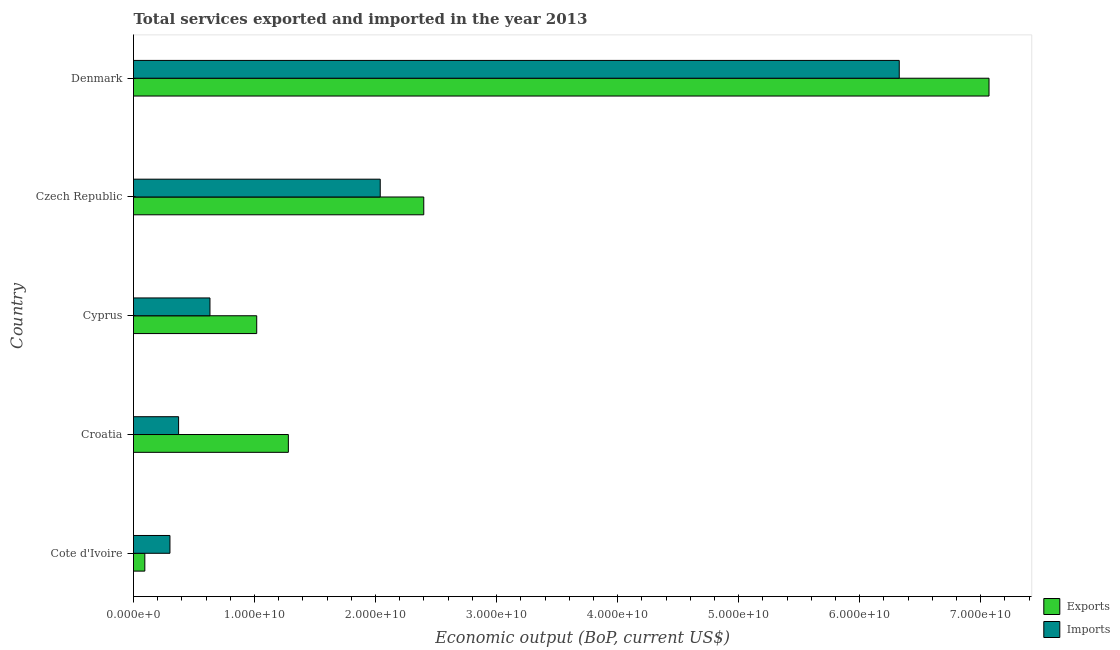How many groups of bars are there?
Keep it short and to the point. 5. Are the number of bars per tick equal to the number of legend labels?
Ensure brevity in your answer.  Yes. Are the number of bars on each tick of the Y-axis equal?
Offer a very short reply. Yes. How many bars are there on the 4th tick from the top?
Your response must be concise. 2. How many bars are there on the 1st tick from the bottom?
Your response must be concise. 2. What is the label of the 3rd group of bars from the top?
Your answer should be compact. Cyprus. In how many cases, is the number of bars for a given country not equal to the number of legend labels?
Your response must be concise. 0. What is the amount of service exports in Czech Republic?
Your response must be concise. 2.40e+1. Across all countries, what is the maximum amount of service imports?
Your response must be concise. 6.33e+1. Across all countries, what is the minimum amount of service exports?
Ensure brevity in your answer.  9.35e+08. In which country was the amount of service exports minimum?
Your answer should be compact. Cote d'Ivoire. What is the total amount of service exports in the graph?
Offer a very short reply. 1.19e+11. What is the difference between the amount of service exports in Cote d'Ivoire and that in Denmark?
Ensure brevity in your answer.  -6.98e+1. What is the difference between the amount of service imports in Czech Republic and the amount of service exports in Cyprus?
Your answer should be compact. 1.02e+1. What is the average amount of service exports per country?
Your response must be concise. 2.37e+1. What is the difference between the amount of service exports and amount of service imports in Cote d'Ivoire?
Your response must be concise. -2.08e+09. In how many countries, is the amount of service imports greater than 40000000000 US$?
Give a very brief answer. 1. What is the ratio of the amount of service imports in Czech Republic to that in Denmark?
Provide a succinct answer. 0.32. Is the difference between the amount of service exports in Cote d'Ivoire and Cyprus greater than the difference between the amount of service imports in Cote d'Ivoire and Cyprus?
Keep it short and to the point. No. What is the difference between the highest and the second highest amount of service exports?
Offer a very short reply. 4.67e+1. What is the difference between the highest and the lowest amount of service imports?
Ensure brevity in your answer.  6.03e+1. What does the 1st bar from the top in Cyprus represents?
Ensure brevity in your answer.  Imports. What does the 2nd bar from the bottom in Croatia represents?
Ensure brevity in your answer.  Imports. How many bars are there?
Your answer should be very brief. 10. How many countries are there in the graph?
Keep it short and to the point. 5. What is the difference between two consecutive major ticks on the X-axis?
Ensure brevity in your answer.  1.00e+1. Does the graph contain any zero values?
Keep it short and to the point. No. How are the legend labels stacked?
Offer a terse response. Vertical. What is the title of the graph?
Offer a terse response. Total services exported and imported in the year 2013. Does "Start a business" appear as one of the legend labels in the graph?
Your answer should be very brief. No. What is the label or title of the X-axis?
Your response must be concise. Economic output (BoP, current US$). What is the Economic output (BoP, current US$) of Exports in Cote d'Ivoire?
Make the answer very short. 9.35e+08. What is the Economic output (BoP, current US$) of Imports in Cote d'Ivoire?
Give a very brief answer. 3.01e+09. What is the Economic output (BoP, current US$) in Exports in Croatia?
Offer a terse response. 1.28e+1. What is the Economic output (BoP, current US$) of Imports in Croatia?
Your response must be concise. 3.73e+09. What is the Economic output (BoP, current US$) of Exports in Cyprus?
Provide a succinct answer. 1.02e+1. What is the Economic output (BoP, current US$) of Imports in Cyprus?
Your answer should be compact. 6.32e+09. What is the Economic output (BoP, current US$) in Exports in Czech Republic?
Your response must be concise. 2.40e+1. What is the Economic output (BoP, current US$) in Imports in Czech Republic?
Your answer should be compact. 2.04e+1. What is the Economic output (BoP, current US$) of Exports in Denmark?
Provide a short and direct response. 7.07e+1. What is the Economic output (BoP, current US$) in Imports in Denmark?
Offer a terse response. 6.33e+1. Across all countries, what is the maximum Economic output (BoP, current US$) of Exports?
Give a very brief answer. 7.07e+1. Across all countries, what is the maximum Economic output (BoP, current US$) in Imports?
Give a very brief answer. 6.33e+1. Across all countries, what is the minimum Economic output (BoP, current US$) in Exports?
Your answer should be compact. 9.35e+08. Across all countries, what is the minimum Economic output (BoP, current US$) in Imports?
Keep it short and to the point. 3.01e+09. What is the total Economic output (BoP, current US$) in Exports in the graph?
Offer a very short reply. 1.19e+11. What is the total Economic output (BoP, current US$) in Imports in the graph?
Offer a terse response. 9.67e+1. What is the difference between the Economic output (BoP, current US$) in Exports in Cote d'Ivoire and that in Croatia?
Provide a succinct answer. -1.19e+1. What is the difference between the Economic output (BoP, current US$) of Imports in Cote d'Ivoire and that in Croatia?
Provide a succinct answer. -7.14e+08. What is the difference between the Economic output (BoP, current US$) in Exports in Cote d'Ivoire and that in Cyprus?
Make the answer very short. -9.25e+09. What is the difference between the Economic output (BoP, current US$) of Imports in Cote d'Ivoire and that in Cyprus?
Make the answer very short. -3.31e+09. What is the difference between the Economic output (BoP, current US$) in Exports in Cote d'Ivoire and that in Czech Republic?
Your answer should be very brief. -2.30e+1. What is the difference between the Economic output (BoP, current US$) of Imports in Cote d'Ivoire and that in Czech Republic?
Make the answer very short. -1.74e+1. What is the difference between the Economic output (BoP, current US$) of Exports in Cote d'Ivoire and that in Denmark?
Ensure brevity in your answer.  -6.98e+1. What is the difference between the Economic output (BoP, current US$) of Imports in Cote d'Ivoire and that in Denmark?
Provide a succinct answer. -6.03e+1. What is the difference between the Economic output (BoP, current US$) of Exports in Croatia and that in Cyprus?
Provide a short and direct response. 2.61e+09. What is the difference between the Economic output (BoP, current US$) in Imports in Croatia and that in Cyprus?
Your answer should be very brief. -2.59e+09. What is the difference between the Economic output (BoP, current US$) in Exports in Croatia and that in Czech Republic?
Your answer should be compact. -1.12e+1. What is the difference between the Economic output (BoP, current US$) of Imports in Croatia and that in Czech Republic?
Keep it short and to the point. -1.67e+1. What is the difference between the Economic output (BoP, current US$) in Exports in Croatia and that in Denmark?
Your answer should be very brief. -5.79e+1. What is the difference between the Economic output (BoP, current US$) in Imports in Croatia and that in Denmark?
Keep it short and to the point. -5.95e+1. What is the difference between the Economic output (BoP, current US$) in Exports in Cyprus and that in Czech Republic?
Offer a terse response. -1.38e+1. What is the difference between the Economic output (BoP, current US$) of Imports in Cyprus and that in Czech Republic?
Provide a short and direct response. -1.41e+1. What is the difference between the Economic output (BoP, current US$) in Exports in Cyprus and that in Denmark?
Provide a short and direct response. -6.05e+1. What is the difference between the Economic output (BoP, current US$) of Imports in Cyprus and that in Denmark?
Offer a very short reply. -5.70e+1. What is the difference between the Economic output (BoP, current US$) in Exports in Czech Republic and that in Denmark?
Provide a short and direct response. -4.67e+1. What is the difference between the Economic output (BoP, current US$) in Imports in Czech Republic and that in Denmark?
Keep it short and to the point. -4.29e+1. What is the difference between the Economic output (BoP, current US$) in Exports in Cote d'Ivoire and the Economic output (BoP, current US$) in Imports in Croatia?
Offer a terse response. -2.79e+09. What is the difference between the Economic output (BoP, current US$) of Exports in Cote d'Ivoire and the Economic output (BoP, current US$) of Imports in Cyprus?
Your answer should be very brief. -5.38e+09. What is the difference between the Economic output (BoP, current US$) in Exports in Cote d'Ivoire and the Economic output (BoP, current US$) in Imports in Czech Republic?
Ensure brevity in your answer.  -1.95e+1. What is the difference between the Economic output (BoP, current US$) in Exports in Cote d'Ivoire and the Economic output (BoP, current US$) in Imports in Denmark?
Provide a short and direct response. -6.23e+1. What is the difference between the Economic output (BoP, current US$) of Exports in Croatia and the Economic output (BoP, current US$) of Imports in Cyprus?
Offer a very short reply. 6.48e+09. What is the difference between the Economic output (BoP, current US$) of Exports in Croatia and the Economic output (BoP, current US$) of Imports in Czech Republic?
Offer a terse response. -7.59e+09. What is the difference between the Economic output (BoP, current US$) of Exports in Croatia and the Economic output (BoP, current US$) of Imports in Denmark?
Offer a terse response. -5.05e+1. What is the difference between the Economic output (BoP, current US$) of Exports in Cyprus and the Economic output (BoP, current US$) of Imports in Czech Republic?
Make the answer very short. -1.02e+1. What is the difference between the Economic output (BoP, current US$) in Exports in Cyprus and the Economic output (BoP, current US$) in Imports in Denmark?
Keep it short and to the point. -5.31e+1. What is the difference between the Economic output (BoP, current US$) in Exports in Czech Republic and the Economic output (BoP, current US$) in Imports in Denmark?
Make the answer very short. -3.93e+1. What is the average Economic output (BoP, current US$) of Exports per country?
Your response must be concise. 2.37e+1. What is the average Economic output (BoP, current US$) of Imports per country?
Offer a very short reply. 1.93e+1. What is the difference between the Economic output (BoP, current US$) of Exports and Economic output (BoP, current US$) of Imports in Cote d'Ivoire?
Provide a succinct answer. -2.08e+09. What is the difference between the Economic output (BoP, current US$) of Exports and Economic output (BoP, current US$) of Imports in Croatia?
Ensure brevity in your answer.  9.07e+09. What is the difference between the Economic output (BoP, current US$) of Exports and Economic output (BoP, current US$) of Imports in Cyprus?
Make the answer very short. 3.86e+09. What is the difference between the Economic output (BoP, current US$) in Exports and Economic output (BoP, current US$) in Imports in Czech Republic?
Your response must be concise. 3.60e+09. What is the difference between the Economic output (BoP, current US$) of Exports and Economic output (BoP, current US$) of Imports in Denmark?
Give a very brief answer. 7.42e+09. What is the ratio of the Economic output (BoP, current US$) of Exports in Cote d'Ivoire to that in Croatia?
Provide a short and direct response. 0.07. What is the ratio of the Economic output (BoP, current US$) of Imports in Cote d'Ivoire to that in Croatia?
Keep it short and to the point. 0.81. What is the ratio of the Economic output (BoP, current US$) in Exports in Cote d'Ivoire to that in Cyprus?
Your answer should be very brief. 0.09. What is the ratio of the Economic output (BoP, current US$) in Imports in Cote d'Ivoire to that in Cyprus?
Ensure brevity in your answer.  0.48. What is the ratio of the Economic output (BoP, current US$) of Exports in Cote d'Ivoire to that in Czech Republic?
Offer a terse response. 0.04. What is the ratio of the Economic output (BoP, current US$) of Imports in Cote d'Ivoire to that in Czech Republic?
Offer a terse response. 0.15. What is the ratio of the Economic output (BoP, current US$) in Exports in Cote d'Ivoire to that in Denmark?
Keep it short and to the point. 0.01. What is the ratio of the Economic output (BoP, current US$) of Imports in Cote d'Ivoire to that in Denmark?
Ensure brevity in your answer.  0.05. What is the ratio of the Economic output (BoP, current US$) of Exports in Croatia to that in Cyprus?
Your answer should be very brief. 1.26. What is the ratio of the Economic output (BoP, current US$) of Imports in Croatia to that in Cyprus?
Your response must be concise. 0.59. What is the ratio of the Economic output (BoP, current US$) of Exports in Croatia to that in Czech Republic?
Provide a short and direct response. 0.53. What is the ratio of the Economic output (BoP, current US$) of Imports in Croatia to that in Czech Republic?
Make the answer very short. 0.18. What is the ratio of the Economic output (BoP, current US$) in Exports in Croatia to that in Denmark?
Provide a succinct answer. 0.18. What is the ratio of the Economic output (BoP, current US$) in Imports in Croatia to that in Denmark?
Keep it short and to the point. 0.06. What is the ratio of the Economic output (BoP, current US$) in Exports in Cyprus to that in Czech Republic?
Keep it short and to the point. 0.42. What is the ratio of the Economic output (BoP, current US$) in Imports in Cyprus to that in Czech Republic?
Make the answer very short. 0.31. What is the ratio of the Economic output (BoP, current US$) in Exports in Cyprus to that in Denmark?
Ensure brevity in your answer.  0.14. What is the ratio of the Economic output (BoP, current US$) in Imports in Cyprus to that in Denmark?
Keep it short and to the point. 0.1. What is the ratio of the Economic output (BoP, current US$) in Exports in Czech Republic to that in Denmark?
Provide a short and direct response. 0.34. What is the ratio of the Economic output (BoP, current US$) of Imports in Czech Republic to that in Denmark?
Your response must be concise. 0.32. What is the difference between the highest and the second highest Economic output (BoP, current US$) of Exports?
Your answer should be compact. 4.67e+1. What is the difference between the highest and the second highest Economic output (BoP, current US$) in Imports?
Offer a very short reply. 4.29e+1. What is the difference between the highest and the lowest Economic output (BoP, current US$) of Exports?
Your response must be concise. 6.98e+1. What is the difference between the highest and the lowest Economic output (BoP, current US$) in Imports?
Keep it short and to the point. 6.03e+1. 